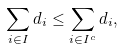<formula> <loc_0><loc_0><loc_500><loc_500>\sum _ { i \in I } d _ { i } \leq \sum _ { i \in I ^ { c } } d _ { i } ,</formula> 